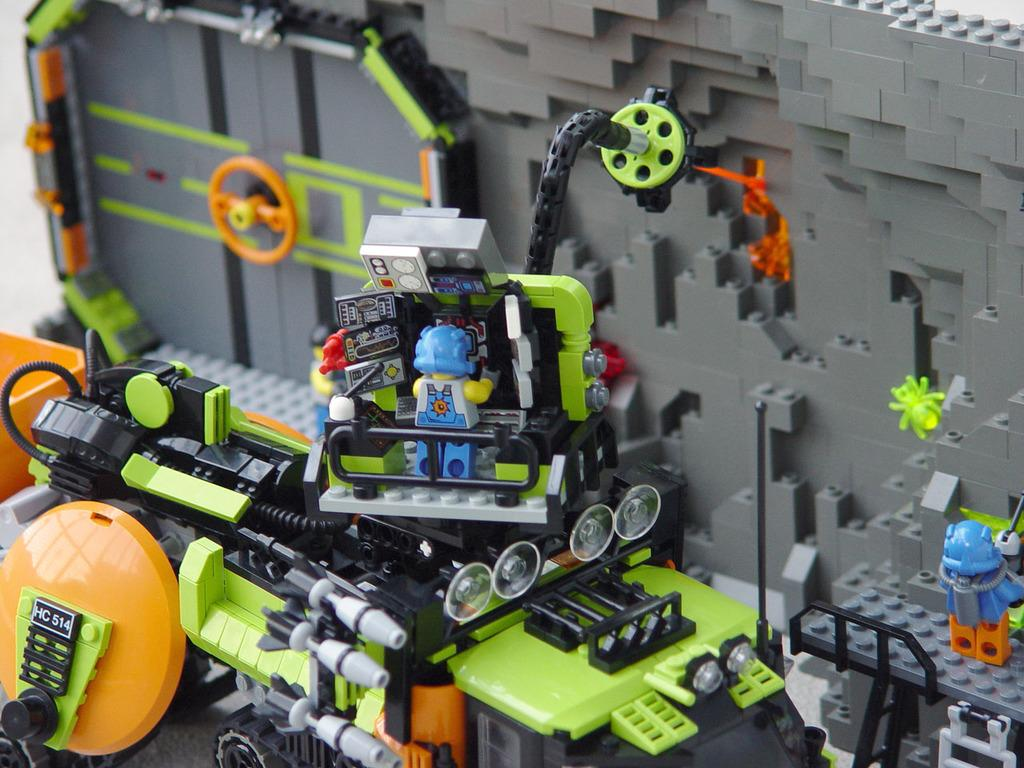What type of toy machine is in the image? There is a Lego toy machine in the image. What features does the toy machine have? The toy machine has lights, a steering wheel, wheels, and toys. Are there any visible wires in the image? Yes, there are wires visible in the image. What can be seen in the background of the image? There is a grey wall in the background of the image. How many men are conducting business in the image? There are no men or business-related activities depicted in the image; it features a Lego toy machine. 